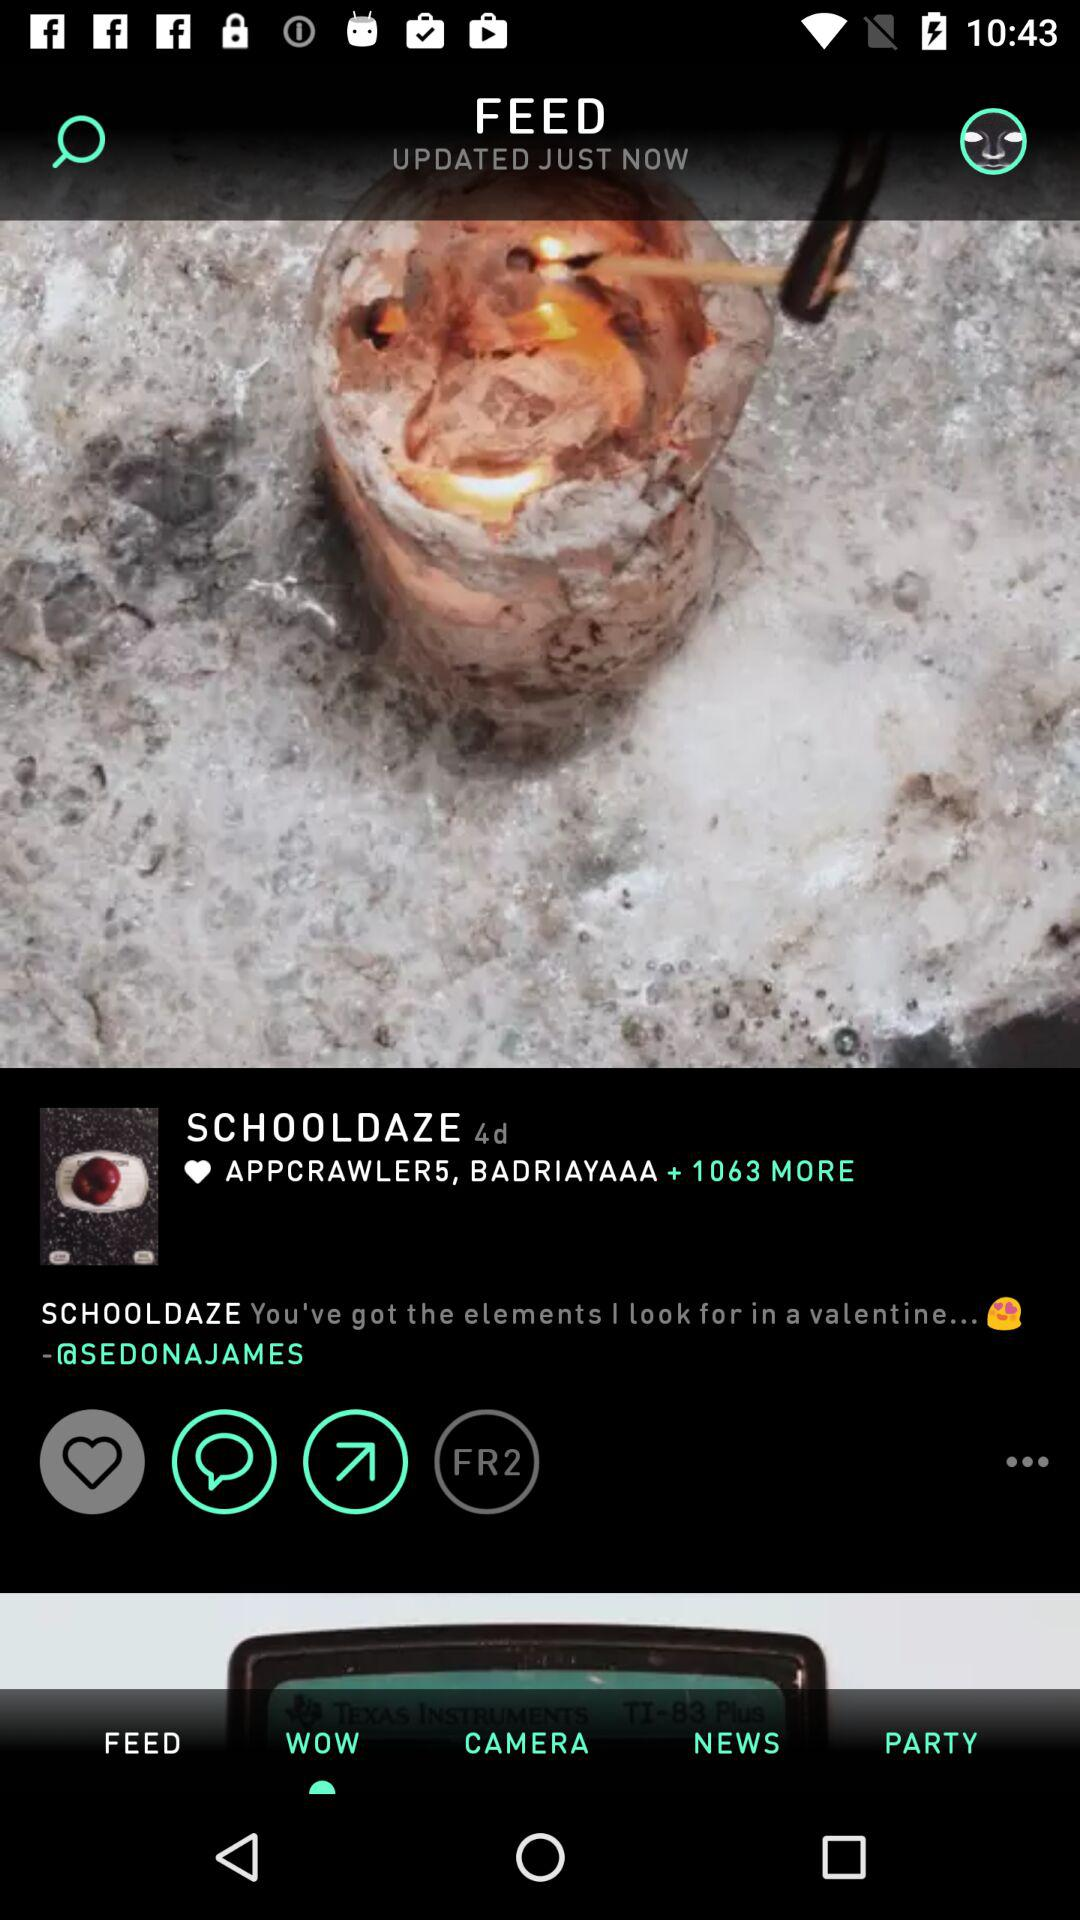How many days ago did "SCHOOLDAZE" post the post? "SCHOOLDAZE" posted the post 4 days ago. 